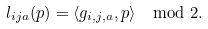Convert formula to latex. <formula><loc_0><loc_0><loc_500><loc_500>l _ { i j a } ( p ) = \langle g _ { i , j , a } , p \rangle \mod 2 .</formula> 